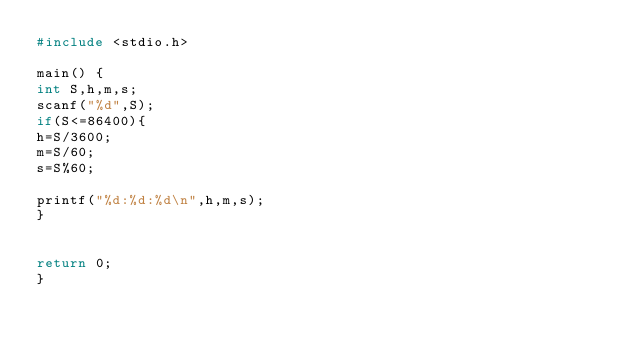Convert code to text. <code><loc_0><loc_0><loc_500><loc_500><_C_>#include <stdio.h>

main() {
int S,h,m,s;
scanf("%d",S);
if(S<=86400){
h=S/3600;
m=S/60;
s=S%60;

printf("%d:%d:%d\n",h,m,s);
}


return 0;
}</code> 